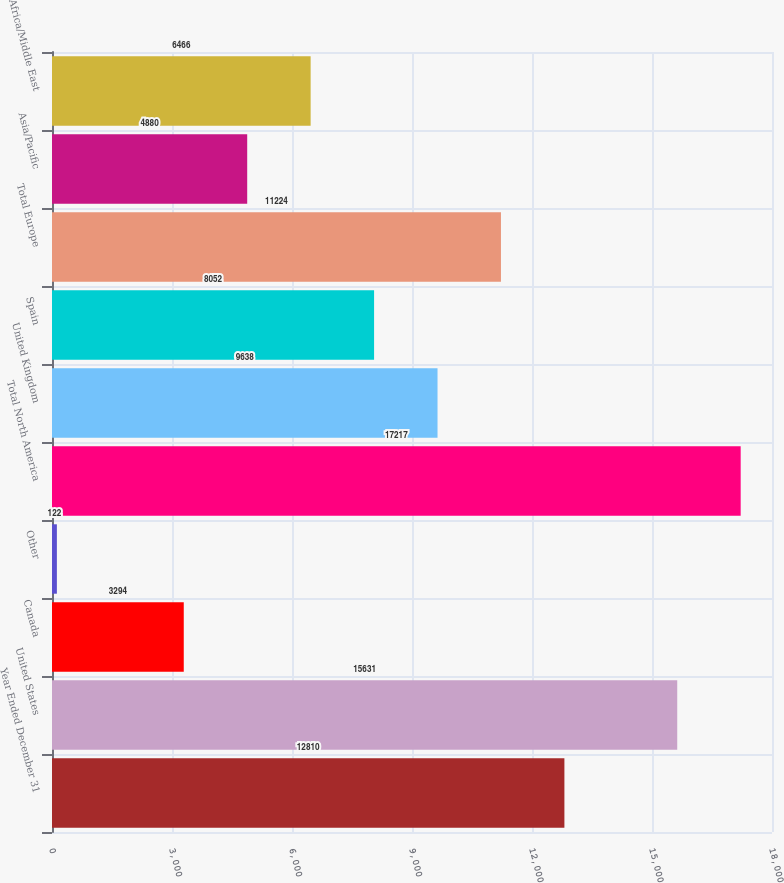Convert chart to OTSL. <chart><loc_0><loc_0><loc_500><loc_500><bar_chart><fcel>Year Ended December 31<fcel>United States<fcel>Canada<fcel>Other<fcel>Total North America<fcel>United Kingdom<fcel>Spain<fcel>Total Europe<fcel>Asia/Pacific<fcel>Africa/Middle East<nl><fcel>12810<fcel>15631<fcel>3294<fcel>122<fcel>17217<fcel>9638<fcel>8052<fcel>11224<fcel>4880<fcel>6466<nl></chart> 